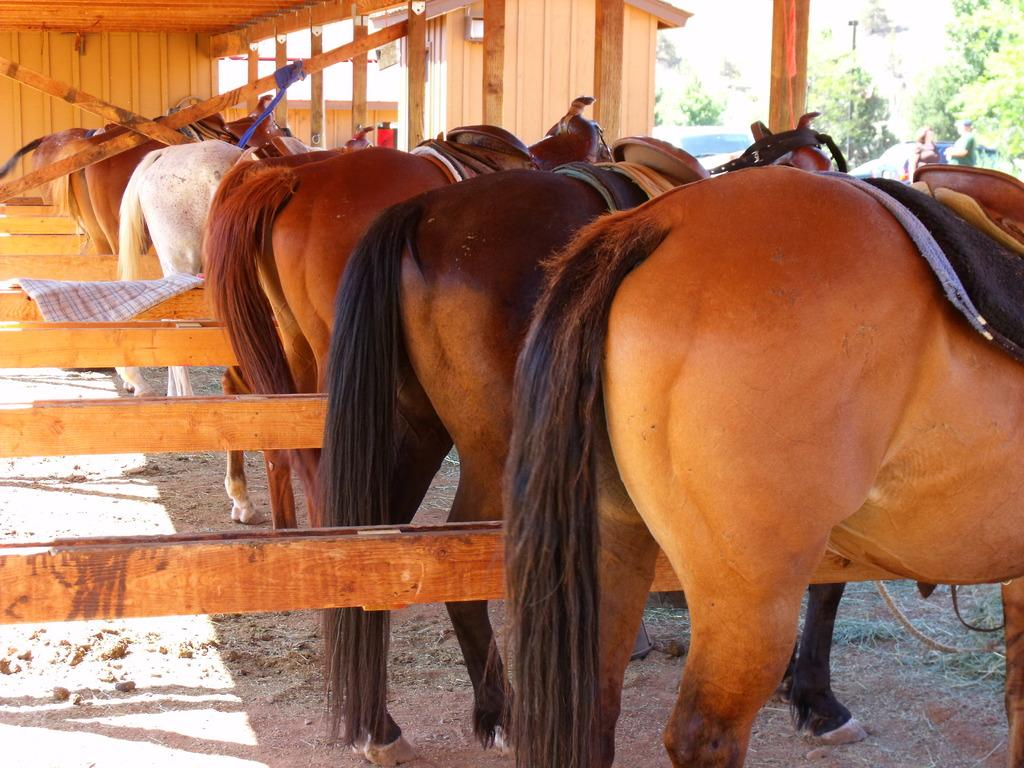What animals are present in the image? There are horses in the image. What is placed on the horses? There are objects on the horses. What can be seen in the background of the image? There is a wall and wooden objects in the background of the image. What is located on the right side of the image? There are trees and people on the right side of the image. Can you tell me how many times the person sneezes in the image? There is no person sneezing in the image; it features horses with objects on them, a wall, wooden objects, trees, and people. What type of flame can be seen on the horses in the image? There are no flames present on the horses or anywhere else in the image. 